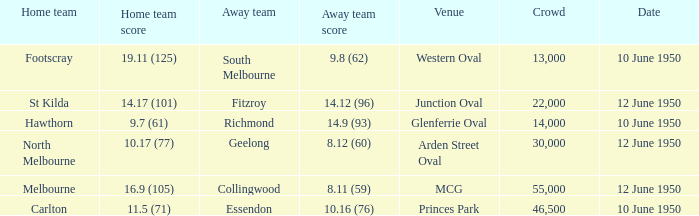Who was the away team when the VFL played at MCG? Collingwood. 